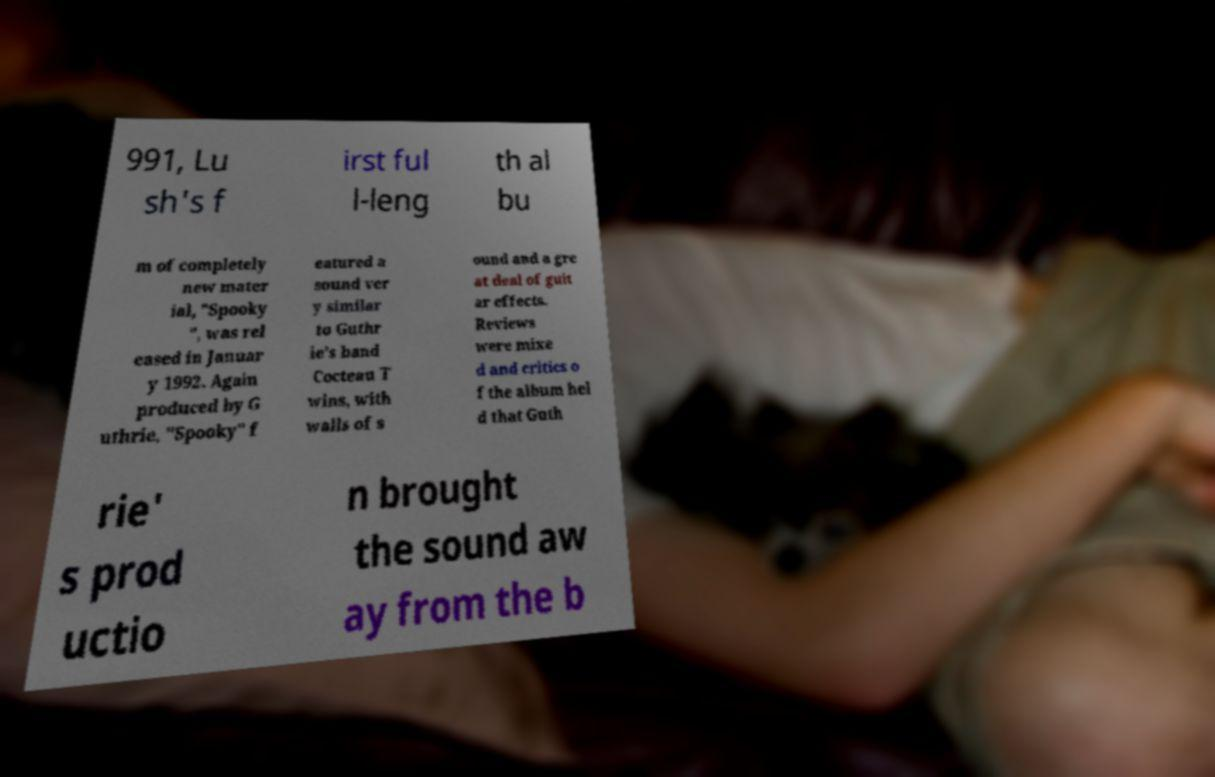Please identify and transcribe the text found in this image. 991, Lu sh's f irst ful l-leng th al bu m of completely new mater ial, "Spooky ", was rel eased in Januar y 1992. Again produced by G uthrie, "Spooky" f eatured a sound ver y similar to Guthr ie's band Cocteau T wins, with walls of s ound and a gre at deal of guit ar effects. Reviews were mixe d and critics o f the album hel d that Guth rie' s prod uctio n brought the sound aw ay from the b 